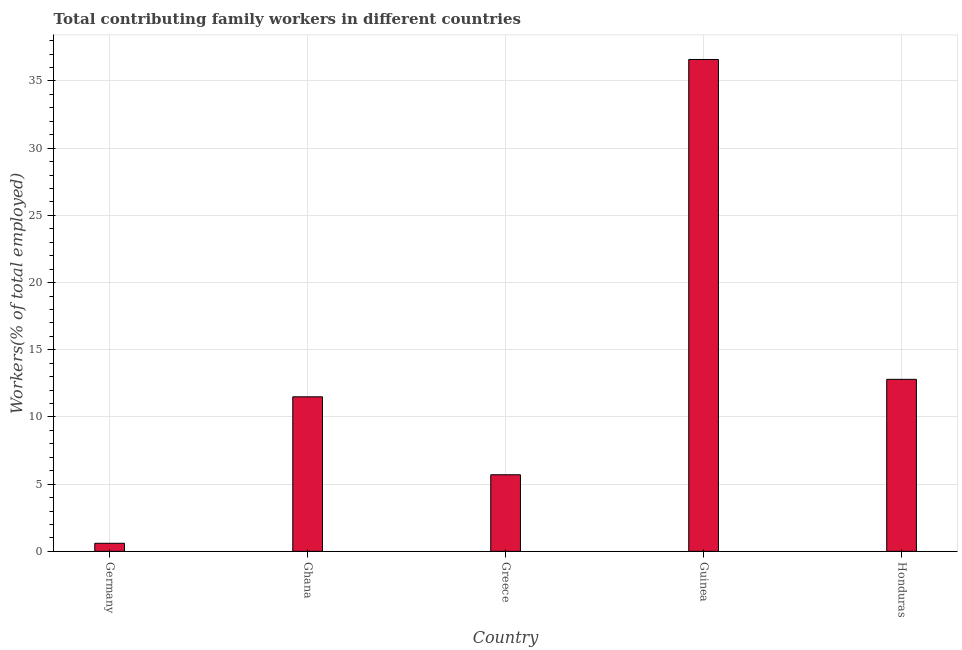Does the graph contain grids?
Ensure brevity in your answer.  Yes. What is the title of the graph?
Your response must be concise. Total contributing family workers in different countries. What is the label or title of the Y-axis?
Ensure brevity in your answer.  Workers(% of total employed). What is the contributing family workers in Germany?
Provide a short and direct response. 0.6. Across all countries, what is the maximum contributing family workers?
Ensure brevity in your answer.  36.6. Across all countries, what is the minimum contributing family workers?
Make the answer very short. 0.6. In which country was the contributing family workers maximum?
Provide a short and direct response. Guinea. In which country was the contributing family workers minimum?
Keep it short and to the point. Germany. What is the sum of the contributing family workers?
Keep it short and to the point. 67.2. What is the difference between the contributing family workers in Guinea and Honduras?
Provide a short and direct response. 23.8. What is the average contributing family workers per country?
Offer a very short reply. 13.44. What is the median contributing family workers?
Keep it short and to the point. 11.5. In how many countries, is the contributing family workers greater than 11 %?
Provide a short and direct response. 3. What is the ratio of the contributing family workers in Ghana to that in Greece?
Your answer should be very brief. 2.02. Is the difference between the contributing family workers in Ghana and Greece greater than the difference between any two countries?
Keep it short and to the point. No. What is the difference between the highest and the second highest contributing family workers?
Offer a terse response. 23.8. What is the difference between the highest and the lowest contributing family workers?
Ensure brevity in your answer.  36. In how many countries, is the contributing family workers greater than the average contributing family workers taken over all countries?
Your answer should be very brief. 1. How many bars are there?
Keep it short and to the point. 5. Are all the bars in the graph horizontal?
Give a very brief answer. No. How many countries are there in the graph?
Your answer should be compact. 5. What is the difference between two consecutive major ticks on the Y-axis?
Make the answer very short. 5. Are the values on the major ticks of Y-axis written in scientific E-notation?
Provide a succinct answer. No. What is the Workers(% of total employed) in Germany?
Make the answer very short. 0.6. What is the Workers(% of total employed) in Ghana?
Ensure brevity in your answer.  11.5. What is the Workers(% of total employed) in Greece?
Provide a short and direct response. 5.7. What is the Workers(% of total employed) in Guinea?
Keep it short and to the point. 36.6. What is the Workers(% of total employed) in Honduras?
Make the answer very short. 12.8. What is the difference between the Workers(% of total employed) in Germany and Ghana?
Offer a very short reply. -10.9. What is the difference between the Workers(% of total employed) in Germany and Guinea?
Your answer should be very brief. -36. What is the difference between the Workers(% of total employed) in Germany and Honduras?
Provide a short and direct response. -12.2. What is the difference between the Workers(% of total employed) in Ghana and Greece?
Give a very brief answer. 5.8. What is the difference between the Workers(% of total employed) in Ghana and Guinea?
Offer a terse response. -25.1. What is the difference between the Workers(% of total employed) in Ghana and Honduras?
Offer a very short reply. -1.3. What is the difference between the Workers(% of total employed) in Greece and Guinea?
Your answer should be compact. -30.9. What is the difference between the Workers(% of total employed) in Guinea and Honduras?
Offer a terse response. 23.8. What is the ratio of the Workers(% of total employed) in Germany to that in Ghana?
Provide a short and direct response. 0.05. What is the ratio of the Workers(% of total employed) in Germany to that in Greece?
Provide a short and direct response. 0.1. What is the ratio of the Workers(% of total employed) in Germany to that in Guinea?
Offer a terse response. 0.02. What is the ratio of the Workers(% of total employed) in Germany to that in Honduras?
Your answer should be very brief. 0.05. What is the ratio of the Workers(% of total employed) in Ghana to that in Greece?
Give a very brief answer. 2.02. What is the ratio of the Workers(% of total employed) in Ghana to that in Guinea?
Provide a succinct answer. 0.31. What is the ratio of the Workers(% of total employed) in Ghana to that in Honduras?
Give a very brief answer. 0.9. What is the ratio of the Workers(% of total employed) in Greece to that in Guinea?
Give a very brief answer. 0.16. What is the ratio of the Workers(% of total employed) in Greece to that in Honduras?
Provide a succinct answer. 0.45. What is the ratio of the Workers(% of total employed) in Guinea to that in Honduras?
Provide a short and direct response. 2.86. 